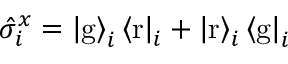Convert formula to latex. <formula><loc_0><loc_0><loc_500><loc_500>\hat { \sigma } _ { i } ^ { x } = \left | g \right \rangle _ { i } \left \langle r \right | _ { i } + \left | r \right \rangle _ { i } \left \langle g \right | _ { i }</formula> 